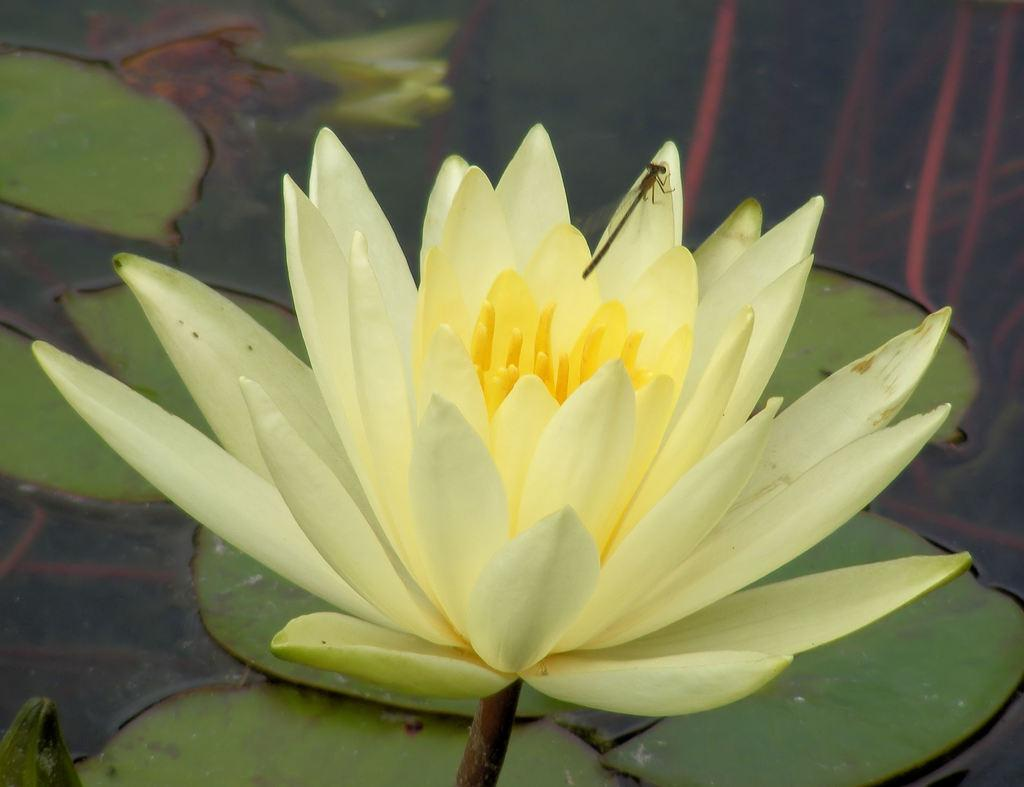What insect can be seen in the image? There is a dragonfly in the image. What is the dragonfly standing on? The dragonfly is standing on a lotus. Where is the lotus located? The lotus is in a pond. Can you tell me how many basketballs are floating in the pond? There are no basketballs present in the image; it features a dragonfly standing on a lotus in a pond. Is there a hen visible in the image? There is no hen present in the image; it features a dragonfly standing on a lotus in a pond. 